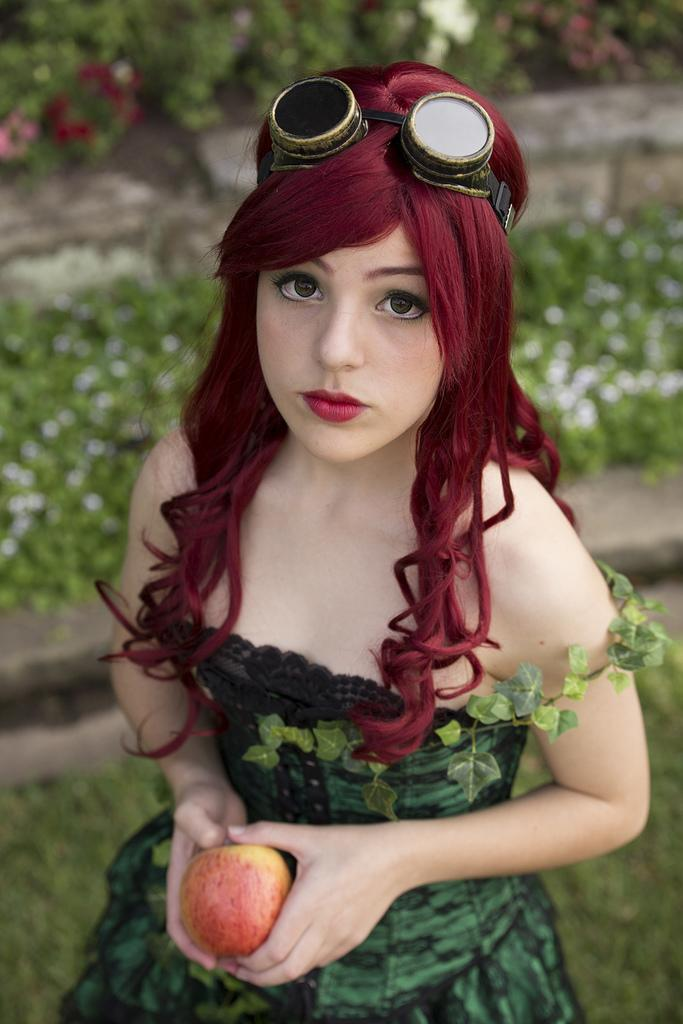Who or what is the main subject of the image? There is a girl in the image. What is the girl holding in her hands? The girl is holding an apple in her hands. Can you describe the background of the image? The background of the image is blurred. Where is the faucet located in the image? There is no faucet present in the image. What type of sail is the girl using in the image? There is no sail or sailing activity depicted in the image; the girl is simply holding an apple. 